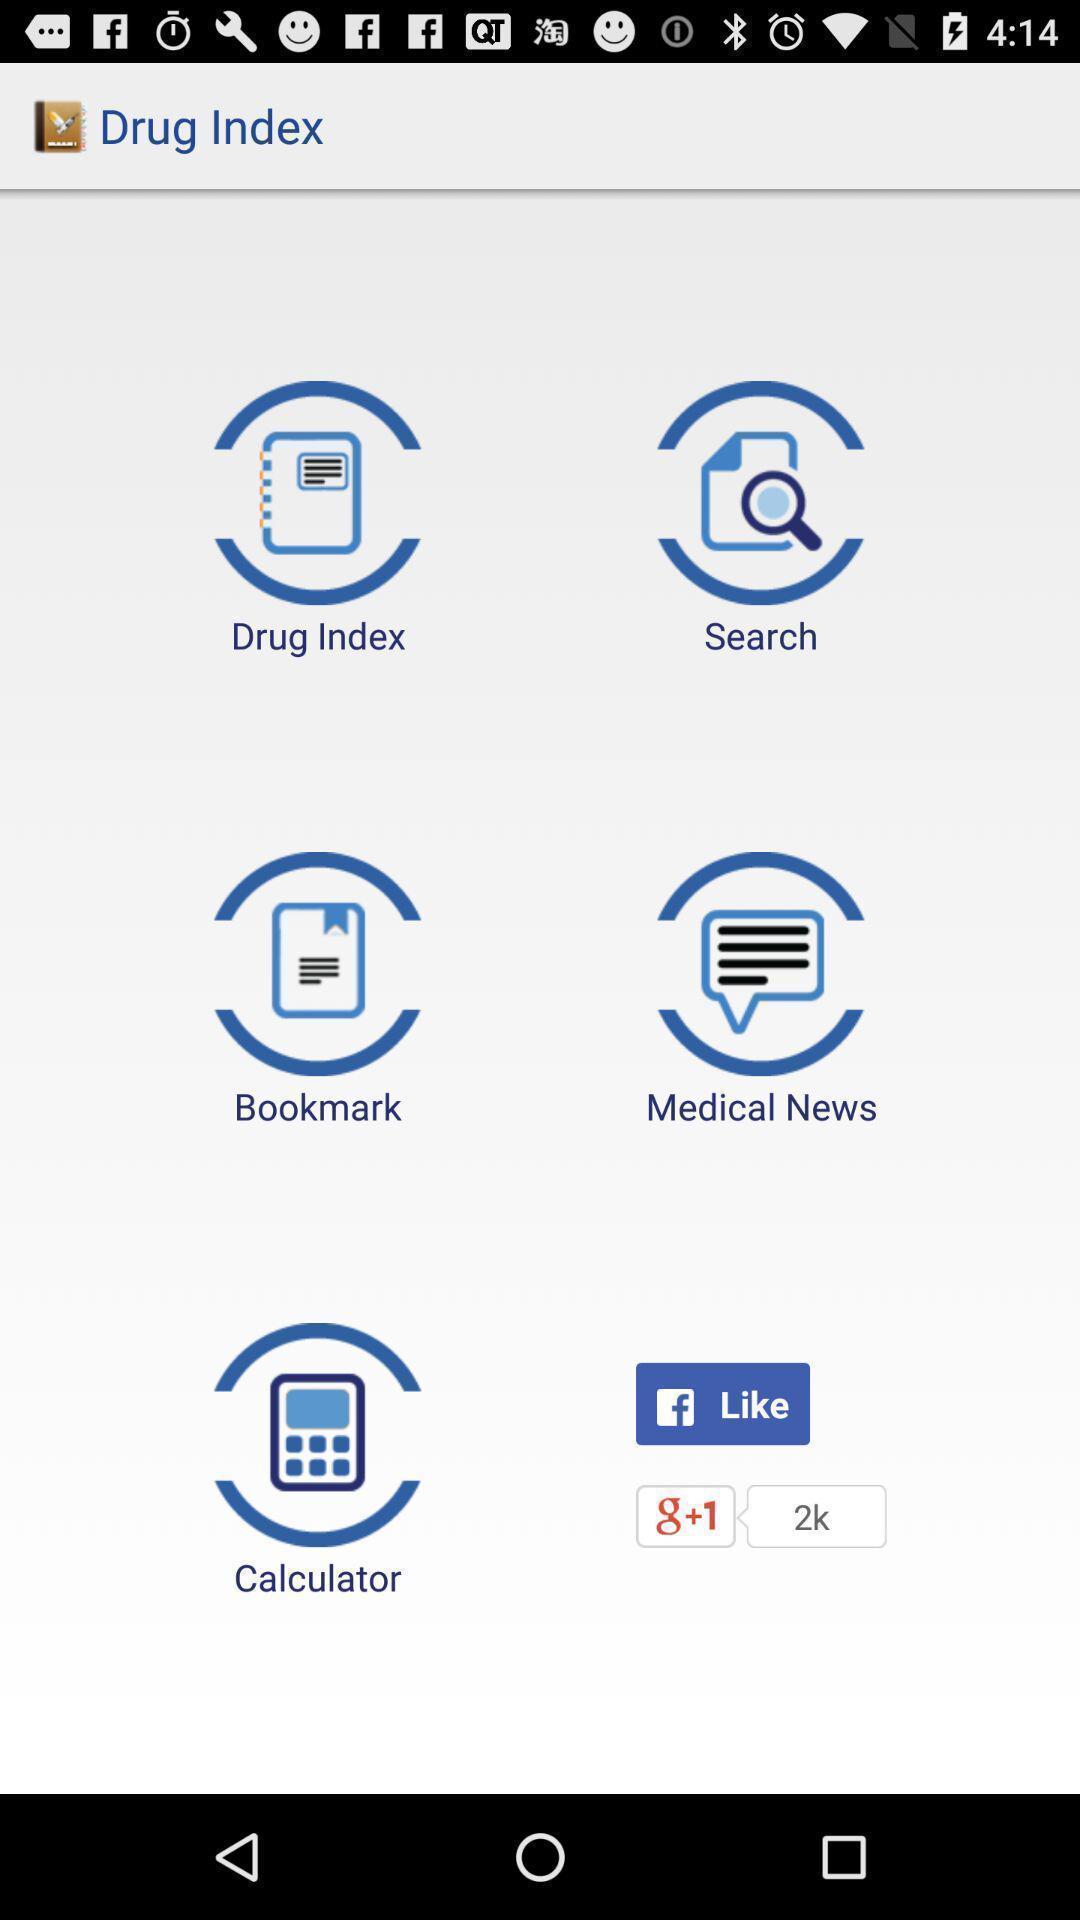Explain what's happening in this screen capture. Page showing search option to find clinical information. 